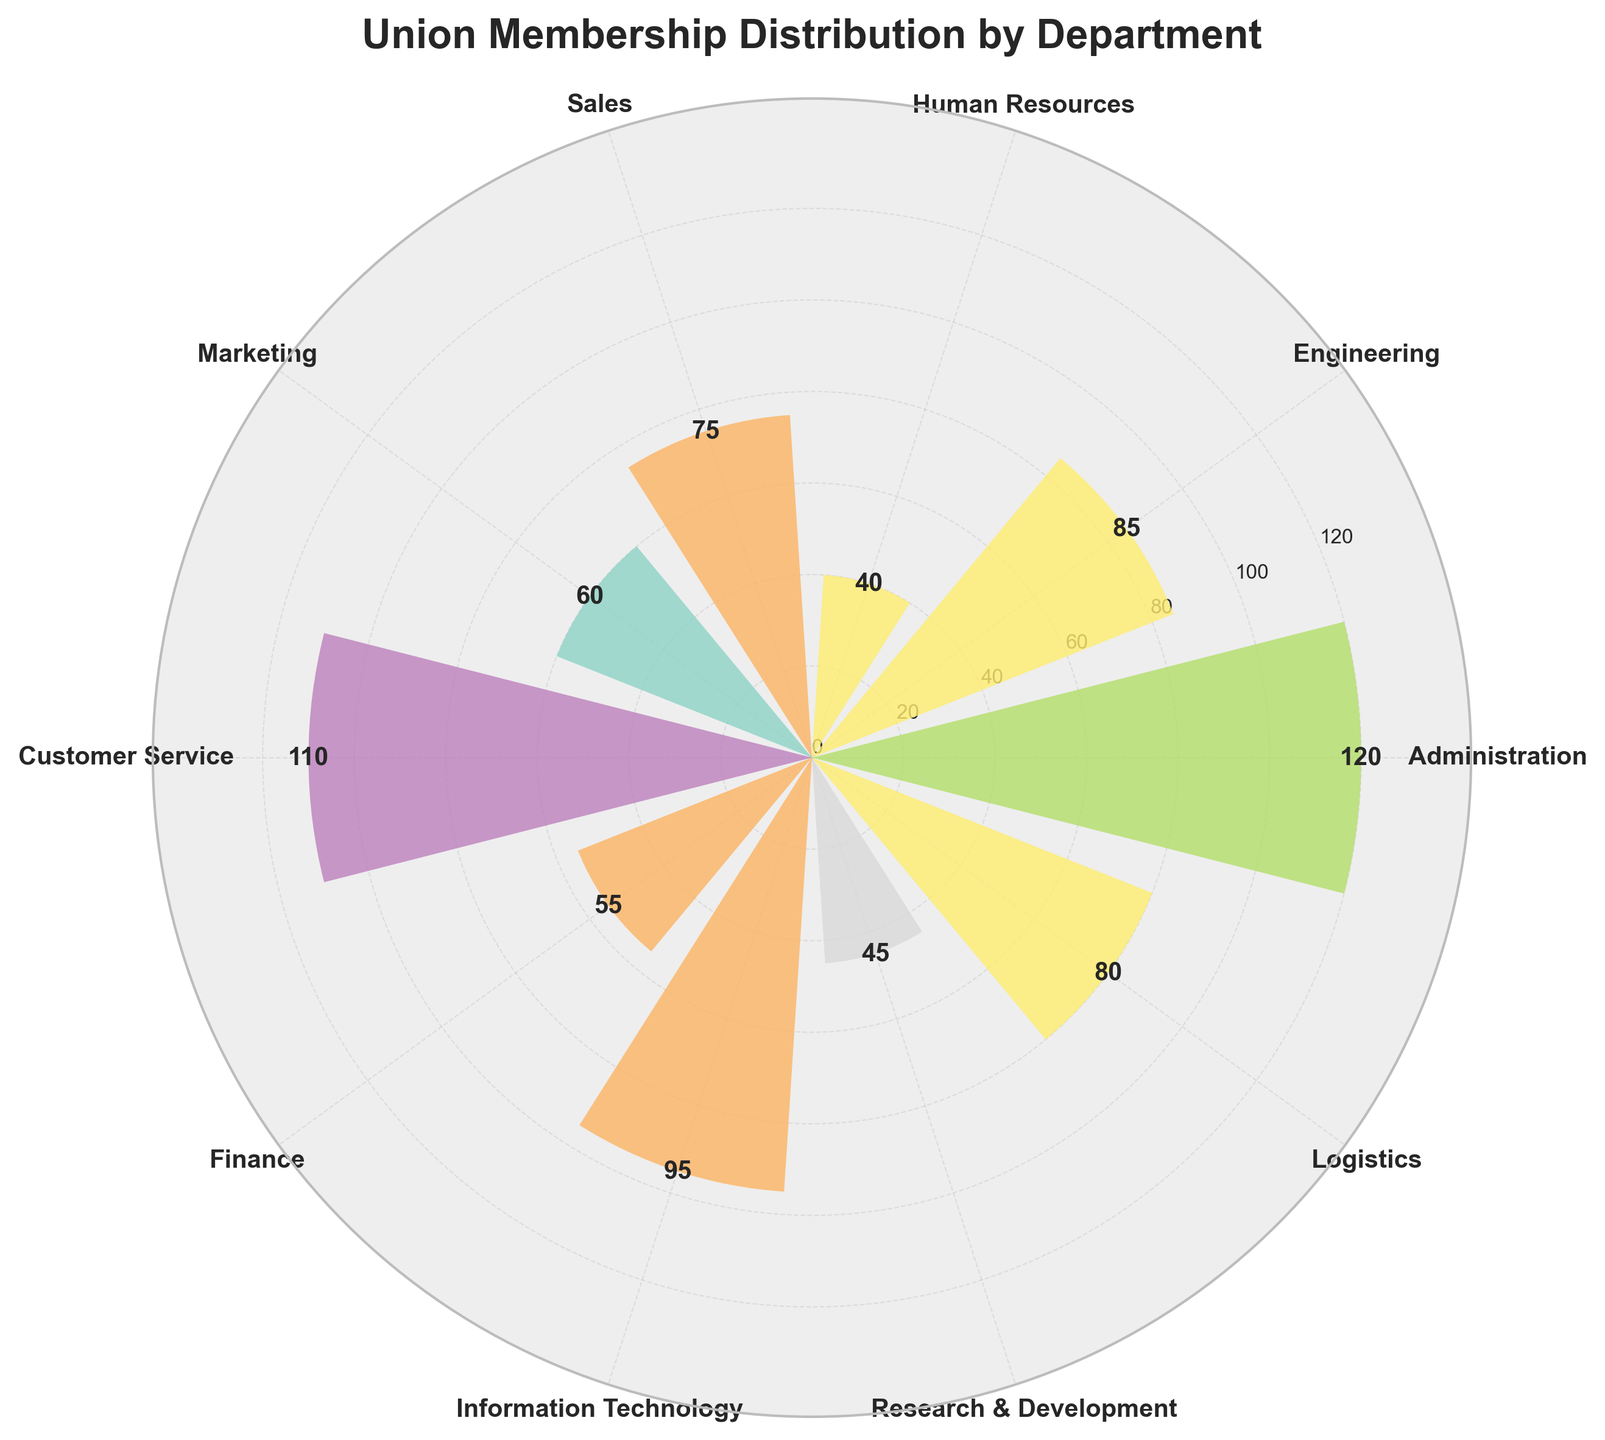How many departments are represented in the polar chart? Count the number of distinct departments labeled around the polar chart ticks.
Answer: 10 Which department has the highest number of union members? Identify the longest bar in the polar chart, which represents the highest value.
Answer: Administration What is the title of the figure? Look at the labeled title at the top of the figure.
Answer: Union Membership Distribution by Department Which department has fewer union members, Sales or Marketing? Compare the bar lengths for Sales and Marketing; the shorter bar represents fewer members.
Answer: Marketing What's the total number of union members in Engineering and Information Technology? Add the number of members in Engineering (85) and Information Technology (95).
Answer: 180 How many Members are in Customer Service? Read the label at the end of the bar representing Customer Service.
Answer: 110 Which department has the least number of union members? Identify the shortest bar in the polar chart.
Answer: Human Resources What is the average number of union members per department? Sum all the members and divide by the number of departments: (120+85+40+75+60+110+55+95+45+80)/10.
Answer: 76.5 Are there more union members in Finance or in Logistics? Compare the bar lengths for Finance and Logistics; the longer bar represents more members.
Answer: Logistics Between which angles are the Administration and Sales departments located? Identify the angular positions of the bars representing these departments. Administration is at 0 radians (or 0 degrees) and Sales is near the middle of the chart but rotated clockwise.
Answer: Administration 0°, Sales approx. 240° 